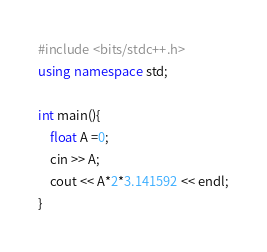Convert code to text. <code><loc_0><loc_0><loc_500><loc_500><_C++_>#include <bits/stdc++.h>
using namespace std;
 
int main(){
    float A =0;
    cin >> A;
    cout << A*2*3.141592 << endl;
}</code> 